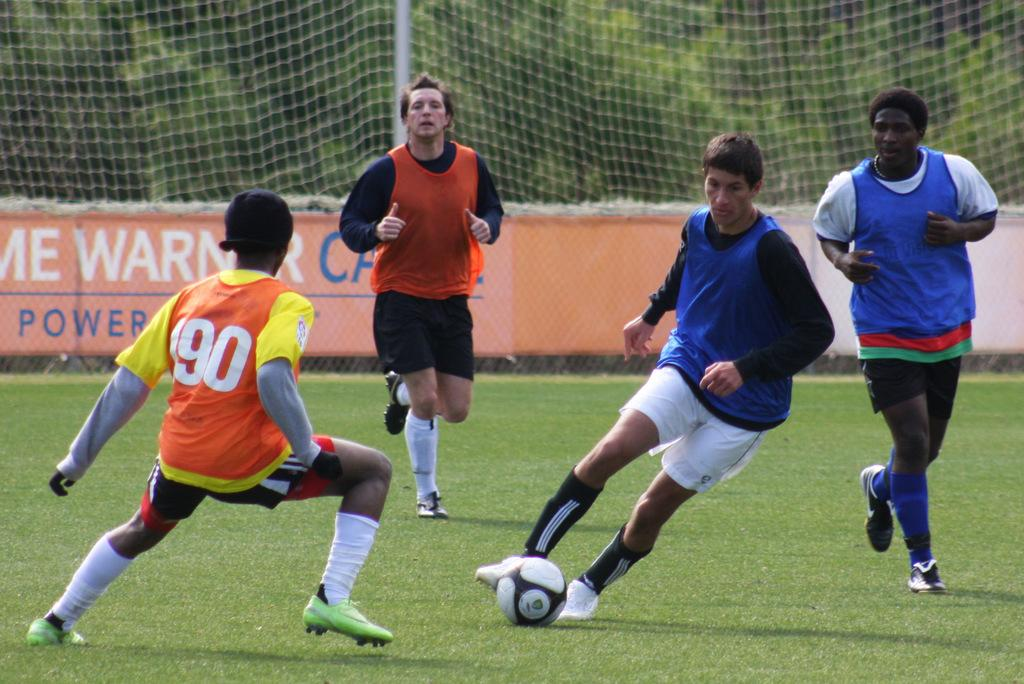Provide a one-sentence caption for the provided image. A boy wearing soccer jersey number 90 is playing defense. 